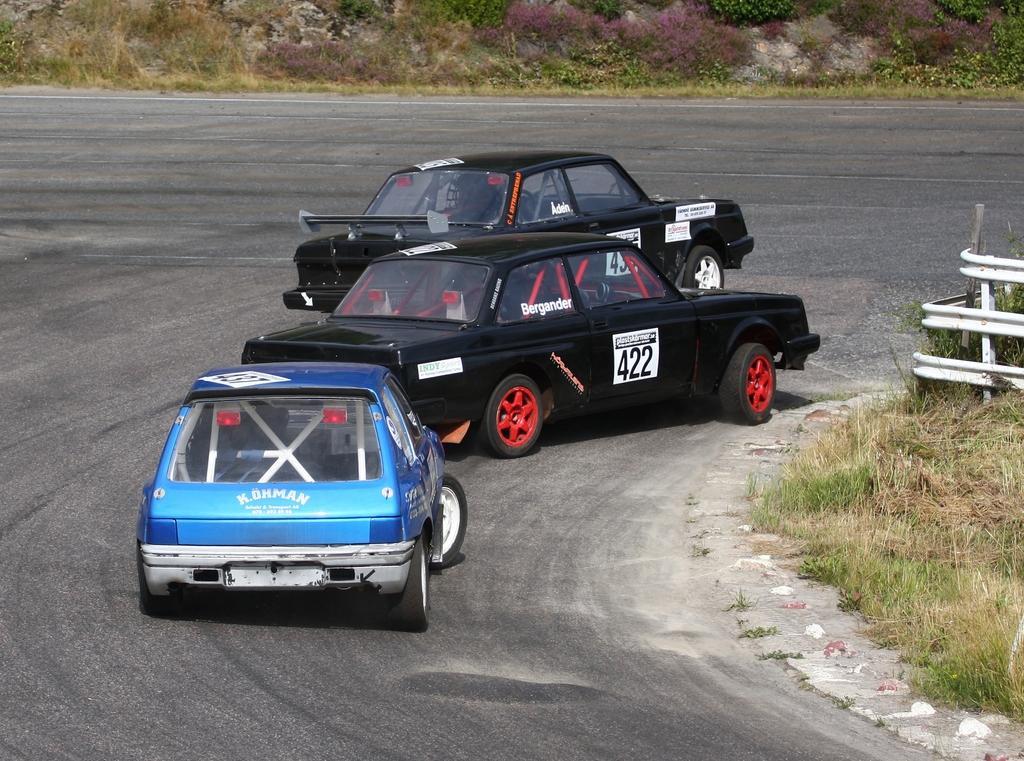In one or two sentences, can you explain what this image depicts? In this picture there are two black cars which are taking the turn. On the left I can see the blue color car on the road. On the right I can see the grass and road fencing. At the top I can see the stones and plants. 